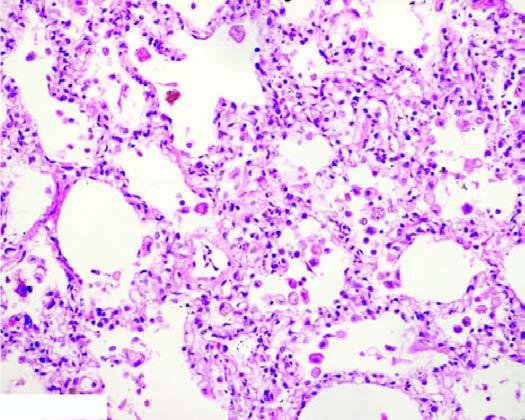re the alveolar septa widened and thickened due to congestion, oedema and mild fibrosis?
Answer the question using a single word or phrase. Yes 